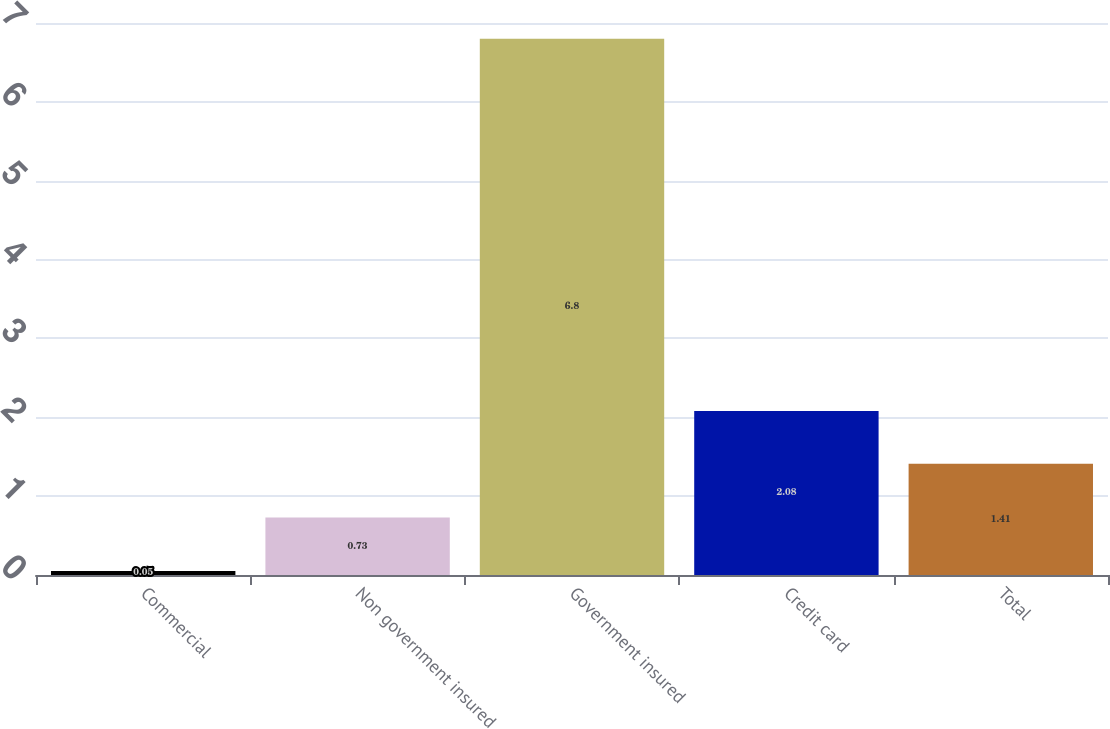Convert chart. <chart><loc_0><loc_0><loc_500><loc_500><bar_chart><fcel>Commercial<fcel>Non government insured<fcel>Government insured<fcel>Credit card<fcel>Total<nl><fcel>0.05<fcel>0.73<fcel>6.8<fcel>2.08<fcel>1.41<nl></chart> 